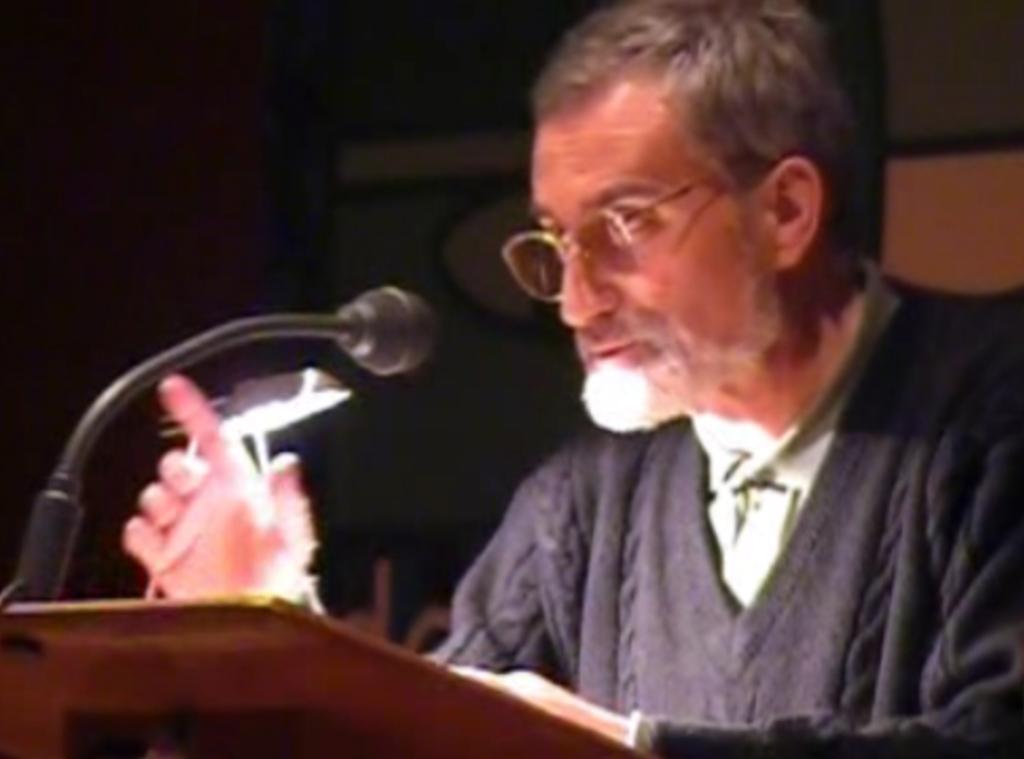What is the main subject of the image? There is a person standing in the image. What is the person doing in the image? The person is speaking. Can you describe any objects in the image? There is a light and a microphone in the image. How would you describe the background of the person? The background of the person is dark. What type of street can be seen in the image? There is no street present in the image; it features a person standing, speaking, and holding a microphone. How many stitches are visible on the person's clothing in the image? There is no mention of stitches or clothing in the provided facts, so it cannot be determined from the image. 